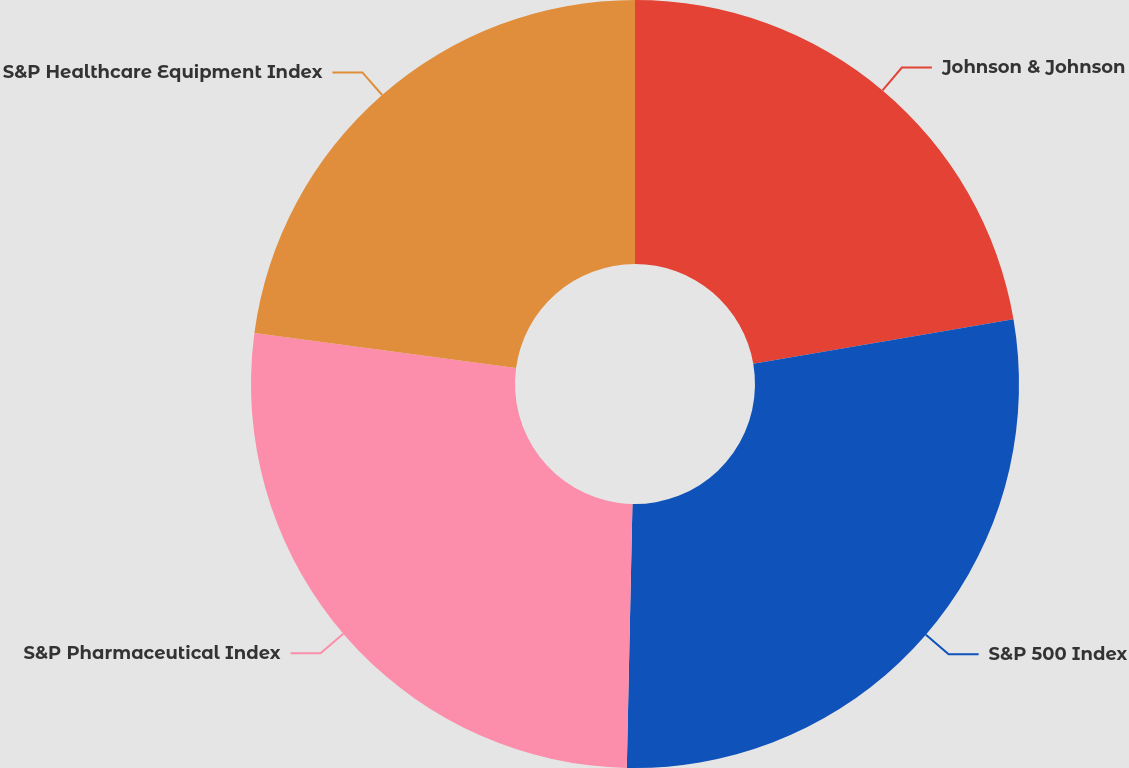Convert chart. <chart><loc_0><loc_0><loc_500><loc_500><pie_chart><fcel>Johnson & Johnson<fcel>S&P 500 Index<fcel>S&P Pharmaceutical Index<fcel>S&P Healthcare Equipment Index<nl><fcel>22.3%<fcel>28.04%<fcel>26.78%<fcel>22.88%<nl></chart> 